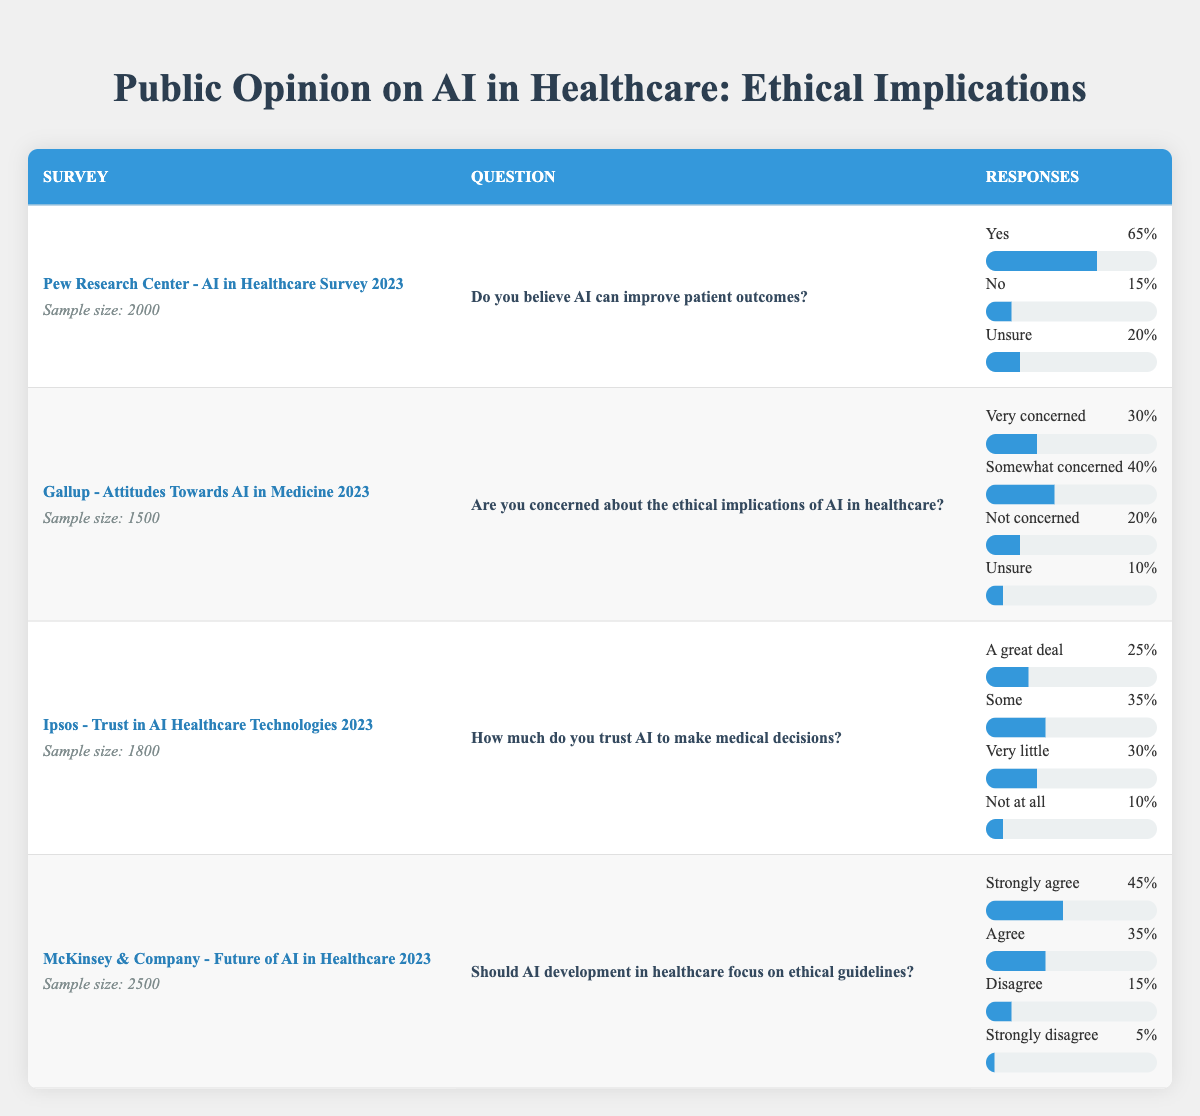What percentage of respondents in the Pew Research Center survey believe AI can improve patient outcomes? The Pew Research Center survey shows that 65% of respondents believe AI can improve patient outcomes. This information is found in the response options for the question in that row.
Answer: 65% What is the sample size of the Gallup survey? The sample size for the Gallup survey is directly stated in that specific row as 1500.
Answer: 1500 How many respondents expressed concern (very concerned and somewhat concerned) about the ethical implications of AI in healthcare in the Gallup survey? To find the total number of respondents concerned about the ethical implications, add the percentages of "Very concerned" (30%) and "Somewhat concerned" (40%) together, which equals 70%.
Answer: 70% Is the percentage of respondents who feel AI should focus on ethical guidelines higher than those who do not have such concerns? In the McKinsey survey, the total percentage of respondents who agree (Strongly agree + Agree = 45% + 35% = 80%) about ethical guidelines is indeed higher than those who disagree (Disagree + Strongly disagree = 15% + 5% = 20%).
Answer: Yes What is the difference between the percentage of respondents who trust AI a great deal versus those who do not trust AI at all? From the Ipsos survey, the percentage of respondents who trust AI a great deal is 25%, while those who do not trust it at all is 10%. The difference is 25% - 10% = 15%.
Answer: 15% What percentage of respondents in the Ipsos survey trust AI "Some" in making medical decisions? According to the Ipsos survey data, 35% of respondents said they trust AI "Some" in making medical decisions. This can be found directly in that row of the table.
Answer: 35% Which survey indicated the highest level of belief that AI can improve patient outcomes, and what was that percentage? The Pew Research Center survey indicated the highest level of belief that AI can improve patient outcomes at 65%. No other surveys in the data provided a higher percentage for this question.
Answer: 65% Are respondents in the McKinsey & Company survey more likely to agree or disagree that AI development in healthcare should focus on ethical guidelines? In the McKinsey survey, 80% (45% + 35%) agreed that AI should focus on ethical guidelines, while only 20% (15% + 5%) disagreed. Thus, respondents are more likely to agree.
Answer: Agree What is the total percentage of respondents who are either "Very concerned" or "Not concerned" about the ethical implications of AI in healthcare in the Gallup survey? For the Gallup survey, "Very concerned" is 30% and "Not concerned" is 20%, which when added together totals 50%.
Answer: 50% 